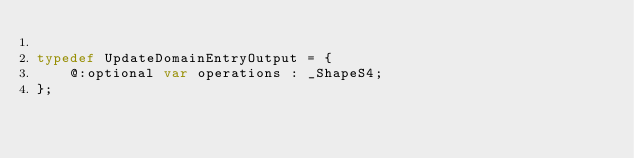Convert code to text. <code><loc_0><loc_0><loc_500><loc_500><_Haxe_>
typedef UpdateDomainEntryOutput = {
    @:optional var operations : _ShapeS4;
};
</code> 